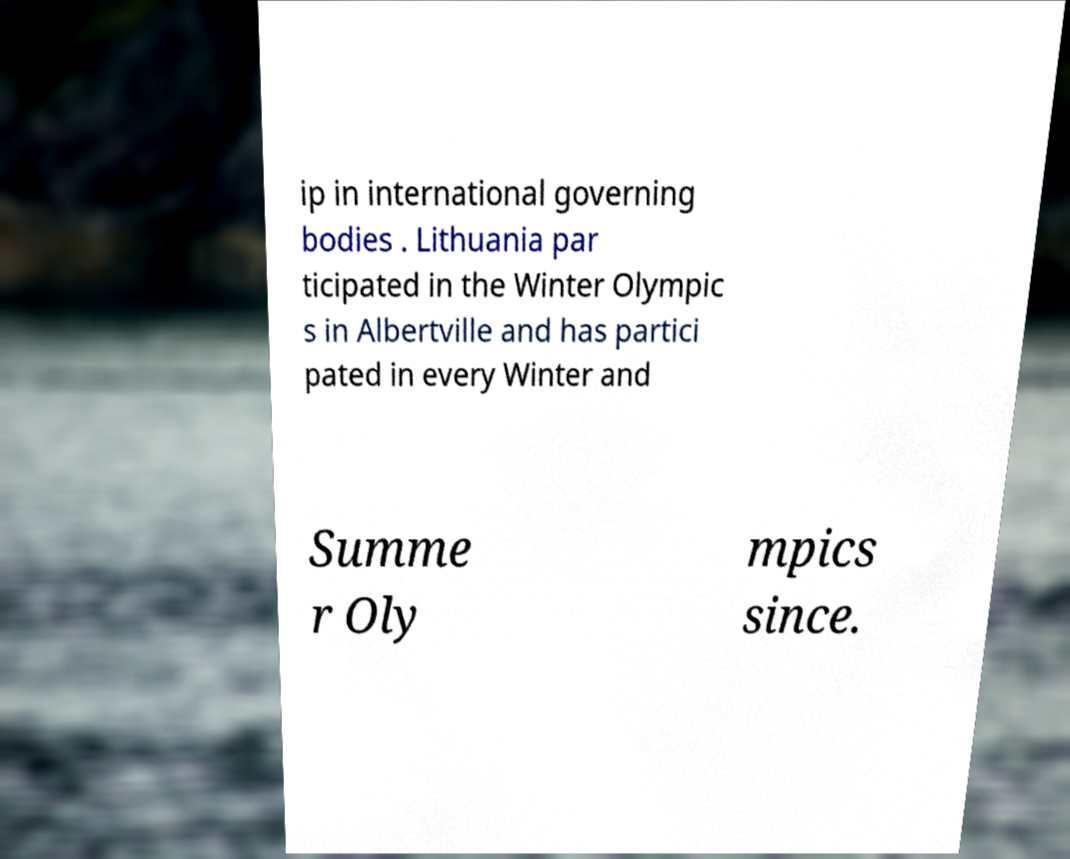Could you extract and type out the text from this image? ip in international governing bodies . Lithuania par ticipated in the Winter Olympic s in Albertville and has partici pated in every Winter and Summe r Oly mpics since. 